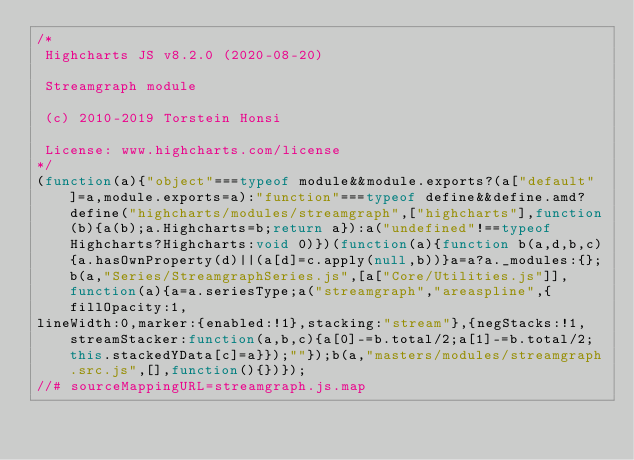<code> <loc_0><loc_0><loc_500><loc_500><_JavaScript_>/*
 Highcharts JS v8.2.0 (2020-08-20)

 Streamgraph module

 (c) 2010-2019 Torstein Honsi

 License: www.highcharts.com/license
*/
(function(a){"object"===typeof module&&module.exports?(a["default"]=a,module.exports=a):"function"===typeof define&&define.amd?define("highcharts/modules/streamgraph",["highcharts"],function(b){a(b);a.Highcharts=b;return a}):a("undefined"!==typeof Highcharts?Highcharts:void 0)})(function(a){function b(a,d,b,c){a.hasOwnProperty(d)||(a[d]=c.apply(null,b))}a=a?a._modules:{};b(a,"Series/StreamgraphSeries.js",[a["Core/Utilities.js"]],function(a){a=a.seriesType;a("streamgraph","areaspline",{fillOpacity:1,
lineWidth:0,marker:{enabled:!1},stacking:"stream"},{negStacks:!1,streamStacker:function(a,b,c){a[0]-=b.total/2;a[1]-=b.total/2;this.stackedYData[c]=a}});""});b(a,"masters/modules/streamgraph.src.js",[],function(){})});
//# sourceMappingURL=streamgraph.js.map</code> 